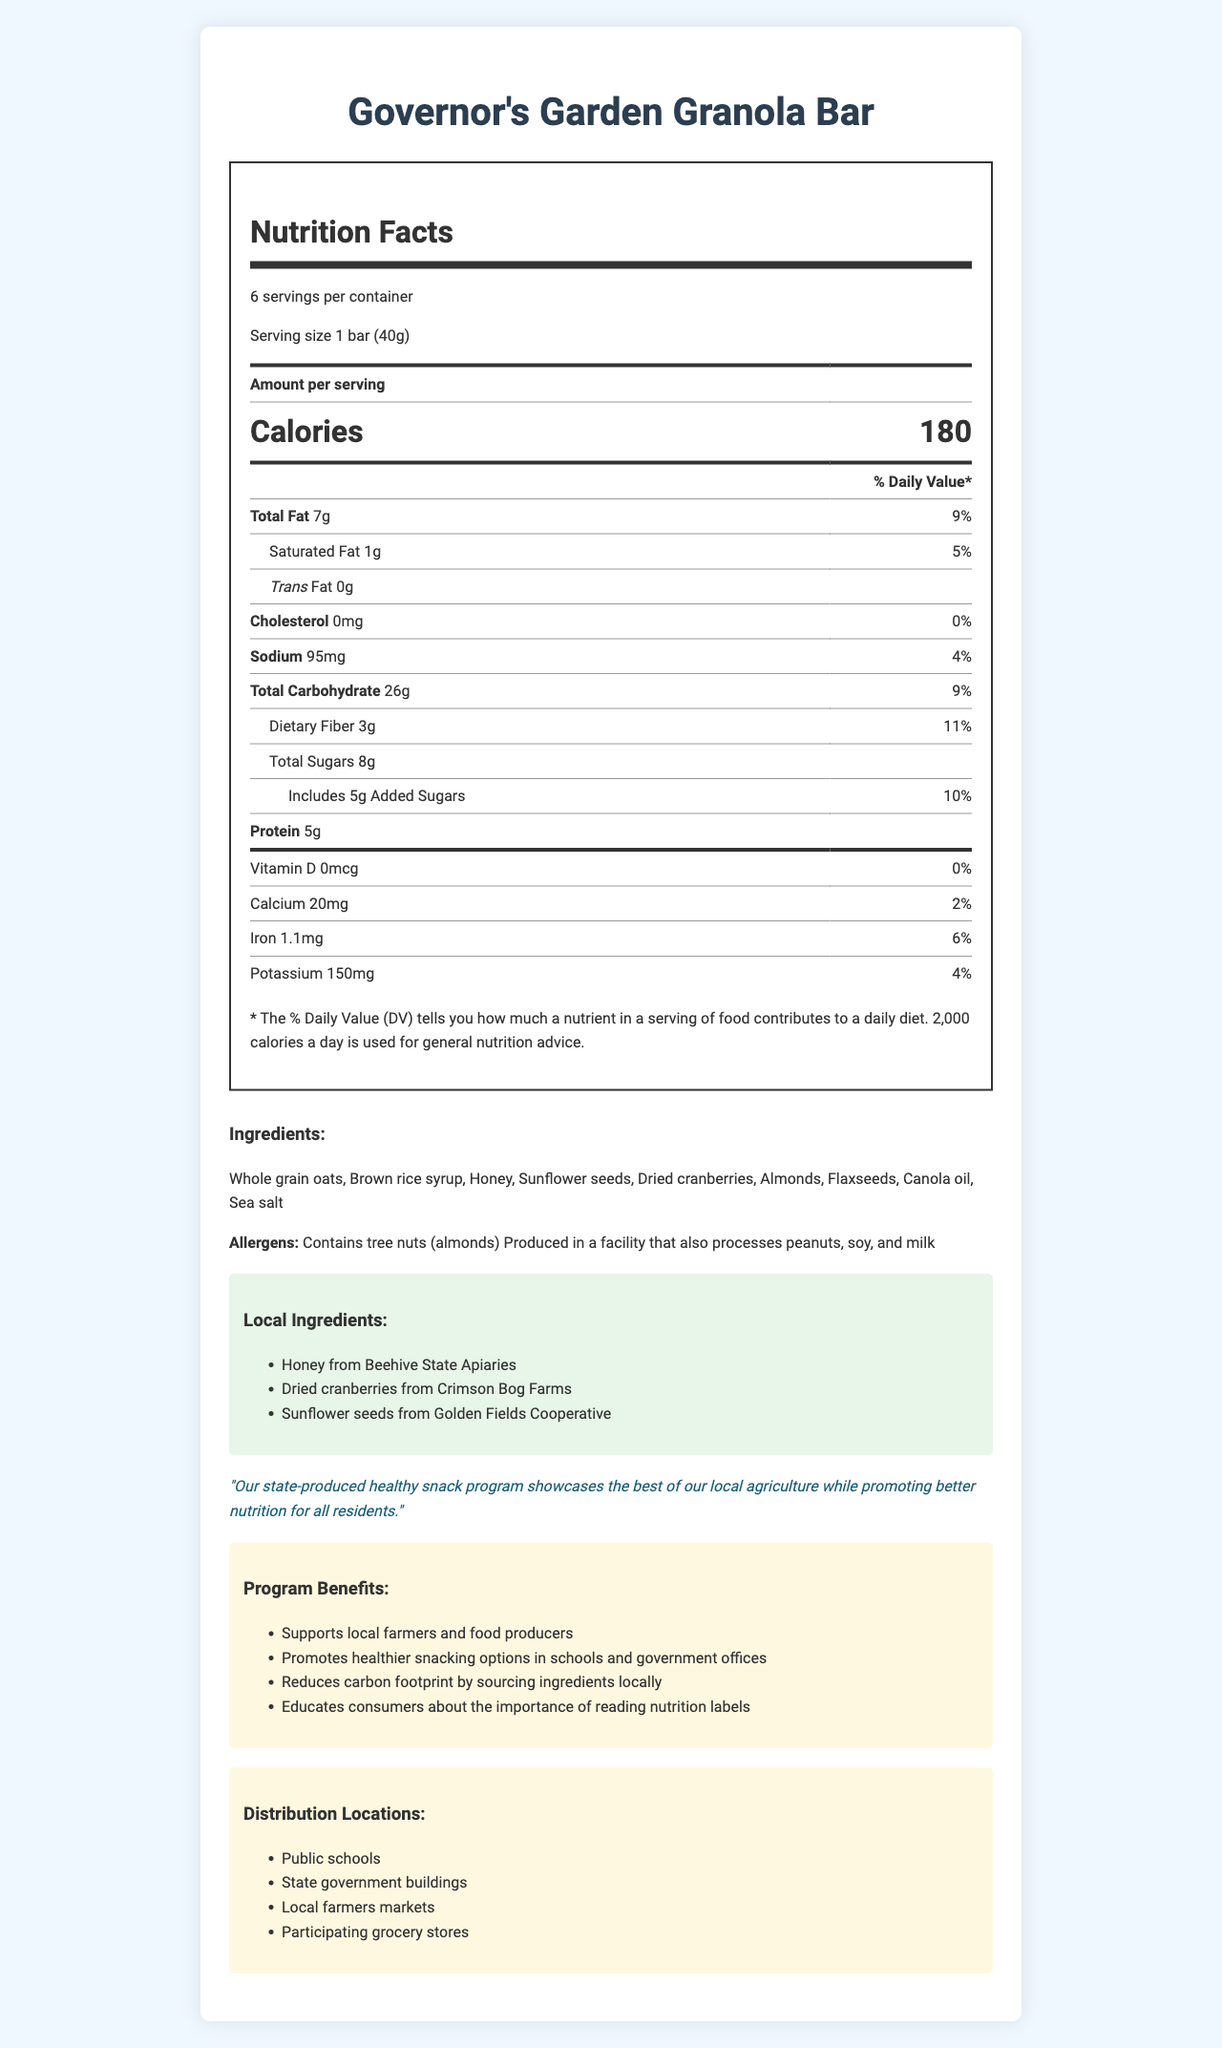what is the product name? The product name is clearly mentioned at the top of the document: "Governor's Garden Granola Bar".
Answer: Governor's Garden Granola Bar what is the serving size of the granola bar? The serving size is mentioned under the nutrition facts section of the document: "Serving size 1 bar (40g)".
Answer: 1 bar (40g) how many calories are in one serving? The amount of calories per serving is listed prominently in the nutrition facts section: "Calories 180".
Answer: 180 which local farm provides the dried cranberries used in the granola bar? The document lists Crimson Bog Farms as the source of dried cranberries under the "Local Ingredients" section.
Answer: Crimson Bog Farms List one of the allergens identified in the ingredients. The allergen information is listed in the ingredients section: "Contains tree nuts (almonds)".
Answer: Contains tree nuts (almonds) How many grams of dietary fiber does one serving contain? A. 1g B. 2g C. 3g D. 4g The document states that each serving contains 3g of dietary fiber.
Answer: C What is the percentage of daily value for added sugars? A. 2% B. 5% C. 10% D. 20% The document lists that added sugars are 5g, which is 10% of the daily value.
Answer: C Does the product contain any trans fat? The document specifies trans fat as "0g," indicating there is no trans fat in the product.
Answer: No Summarize the document in one sentence. The document contains various sections including the nutrition facts label, ingredient list, local ingredient sources, governor's statement, program benefits, and distribution locations.
Answer: The document provides detailed nutrition facts, ingredient information, local sourcing details, and distribution locations for the Governor's Garden Granola Bar, emphasizing local agriculture and healthy snacking. How many grams of protein are in each serving of the granola bar? The nutrition facts section lists that each serving contains 5g of protein.
Answer: 5g Which organization provides the honey for the granola bar? The local ingredient section indicates that the honey is sourced from Beehive State Apiaries.
Answer: Beehive State Apiaries What is the main goal of the state-produced healthy snack program? The governor's statement specifically mentions promoting better nutrition for all residents while showcasing local agriculture.
Answer: Promotes better nutrition for all residents by showcasing local agriculture. What is the amount of sodium per serving in the granola bar? The nutrition facts section specifies that each serving contains 95mg of sodium.
Answer: 95mg Where can you find the granola bar according to the document? A. International Markets B. Local Farmers Markets C. Online Stores The document lists "Local farmers markets" as one of the distribution locations for the granola bar.
Answer: B Does the granola bar contain Vitamin D? The nutrition facts section indicates 0mcg of Vitamin D, which corresponds to 0% of the daily value.
Answer: No Who is the primary audience for the nutrition label on the granola bar? The document does not specify a primary audience directly.
Answer: Cannot be determined Does this product support local farmers? Explain. The document mentions that the state-produced healthy snack program supports local farmers and food producers, which is listed under "Program Benefits".
Answer: Yes 